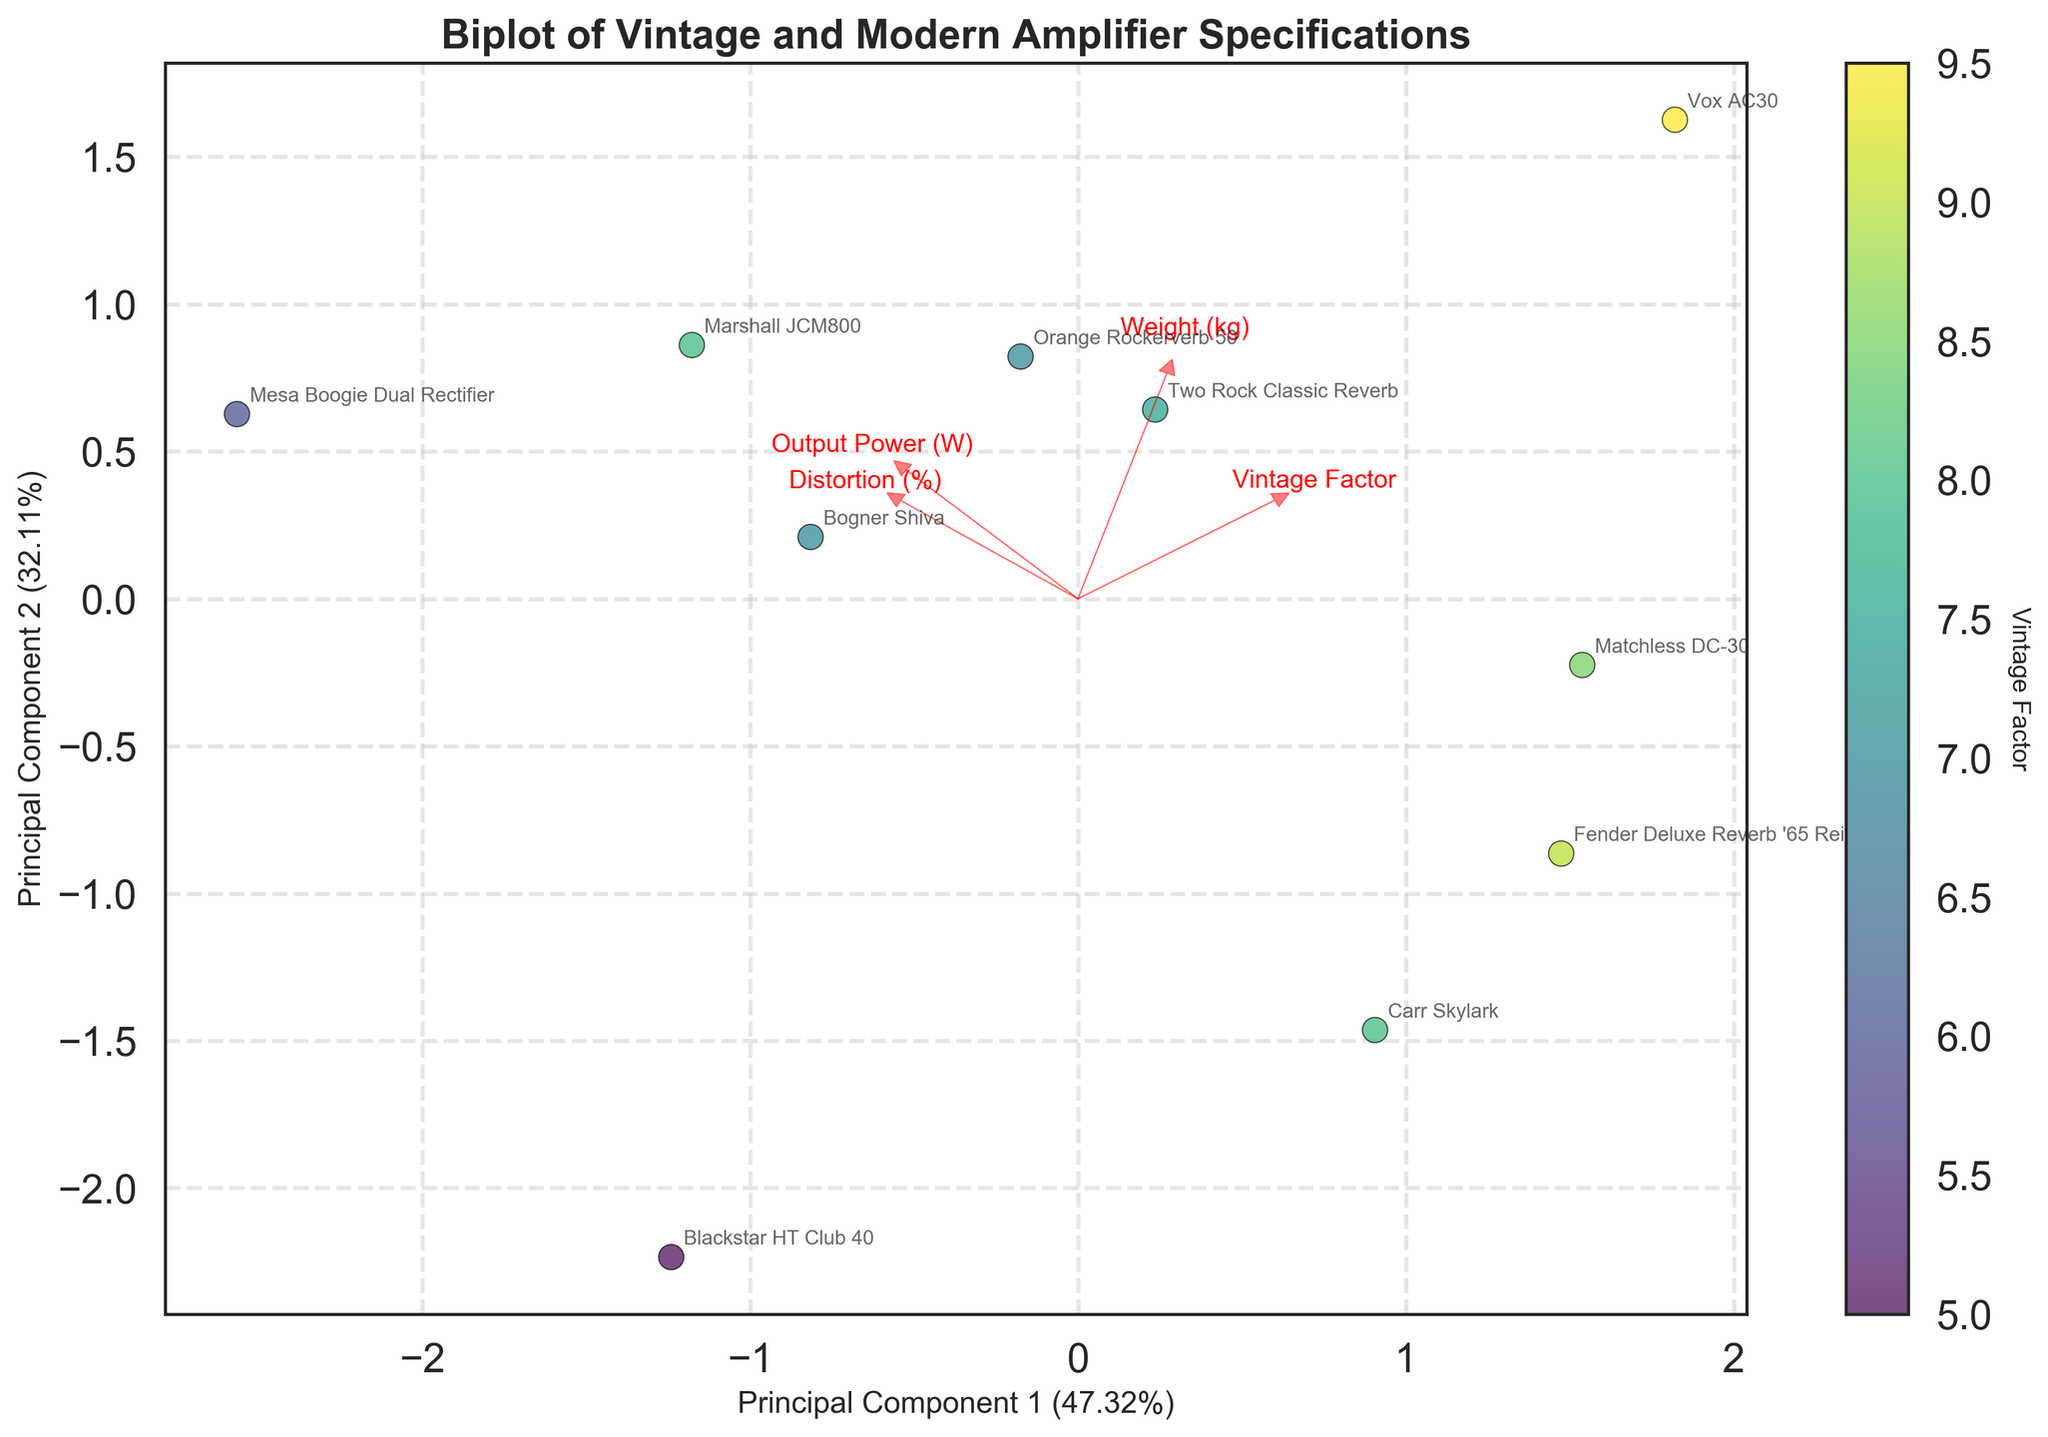How many amplifiers are shown in the biplot? Count the number of points scattered on the plot. Each point represents an amplifier.
Answer: 10 What does the color of the data points represent in the biplot? The colorbar indicates that the color of the data points represents the 'Vintage Factor' of the amplifiers.
Answer: Vintage Factor Which amplifier is represented by the point with the highest 'Vintage Factor'? Locate the data point with the darkest color (as per the color map) and check the label associated with it.
Answer: Vox AC30 Which feature seems to have the largest influence along Principal Component 1? Look at the feature vectors (arrows) and identify which vector is longest in the horizontal direction (Principal Component 1).
Answer: Output Power (W) How does the Fender Deluxe Reverb '65 Reissue compare to the Orange Rockerverb 50 in terms of Principal Component 2? Locate both amplifiers on the plot and compare their positions on the vertical axis (Principal Component 2).
Answer: Fender Deluxe Reverb '65 Reissue is higher Which amplifier has the least distortion, and how is it represented on the plot in relation to Principal Component 2? Identify the amplifier with the smallest 'Distortion (%)' value and check its corresponding position on the vertical axis in the plot.
Answer: Two Rock Classic Reverb; It is one of the amplifiers positioned lower along Principal Component 2 Which amplifier is represented by the point closest to the origin (0,0) on the biplot? Determine the distance of each point to the origin (0,0) and identify the closest one based on their coordinates.
Answer: Bogner Shiva Considering Principal Component 1 and Principal Component 2, which amplifier has a high output power and a balanced vintage factor? Find an amplifier with a positive score in both Principal Component 1 and 2 and has an intermediate 'Vintage Factor' color.
Answer: Marshall JCM800 